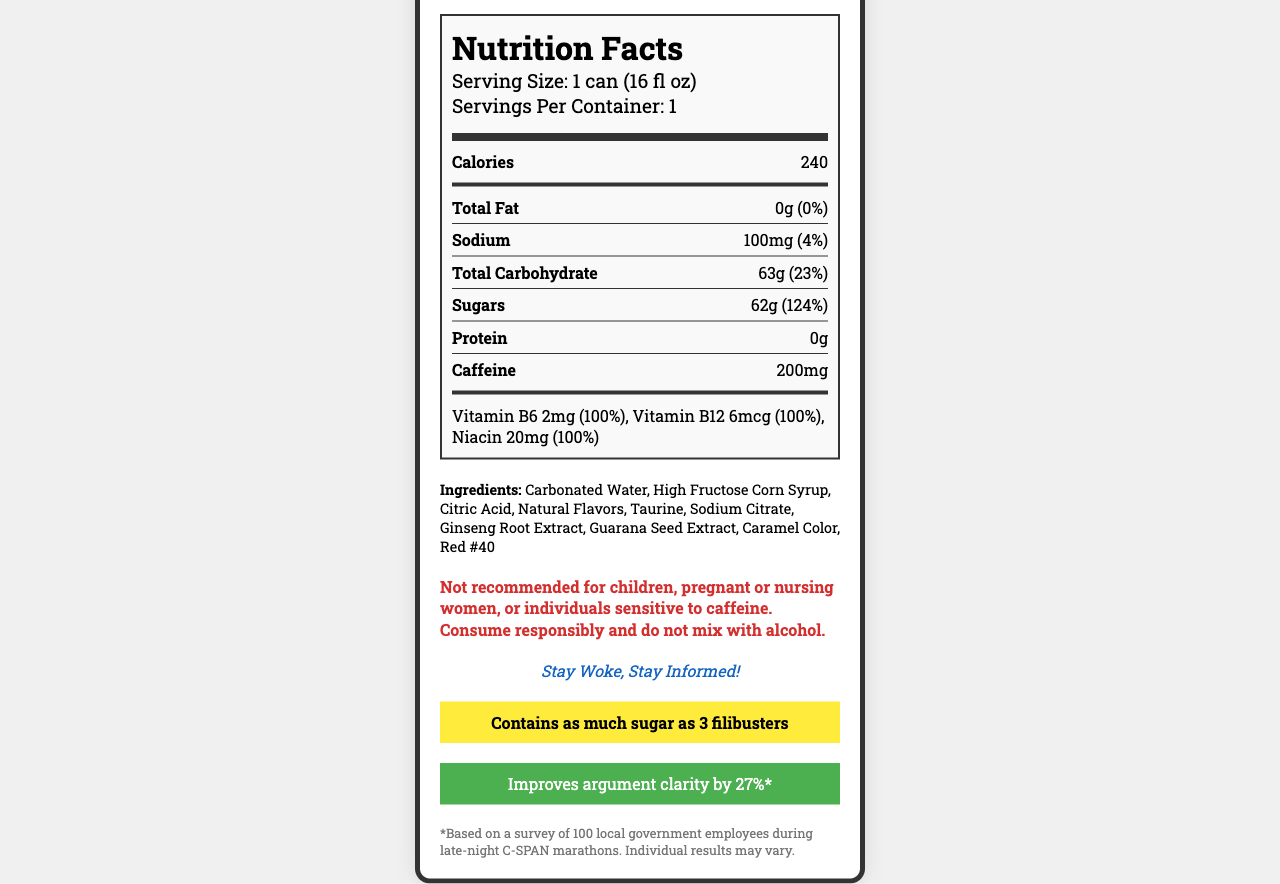what is the product name? The product name is prominently displayed at the top of the document.
Answer: PolitiBoost Energy how many servings are in one container? The document states there is one serving per container.
Answer: 1 what is the serving size? The serving size is listed right below the product name and servings per container information.
Answer: 1 can (16 fl oz) how many calories are in one serving? The number of calories per serving is listed at the beginning of the Nutrition Facts section.
Answer: 240 how much caffeine does this product contain? The amount of caffeine is listed towards the bottom of the nutrient rows.
Answer: 200mg what is the daily value percentage of sugars? The daily value percentage for sugars is provided right next to its amount.
Answer: 124% which vitamin is not present in the list? A. Vitamin C B. Vitamin B12 C. Vitamin B6 D. Niacin The document lists Vitamin B6, Vitamin B12, and Niacin. Vitamin C is not listed.
Answer: A what is the amount of sodium in one serving? The sodium content is listed under the nutrient rows.
Answer: 100mg which ingredient is listed first? A. Citric Acid B. Carbonated Water C. Caffeine D. Taurine The first ingredient listed is Carbonated Water.
Answer: B does this product contain any allergens? The document states that it is manufactured in a facility that processes soy and milk products.
Answer: Yes is this product recommended for children? There is a warning explicitly stating it is not recommended for children.
Answer: No summarize the main idea of the document. The document provides comprehensive information about the energy drink including nutrition content, ingredients, warnings, and promotional claims to give consumers a clear understanding of the product.
Answer: The document details the nutrition facts, ingredients, and some promotional claims of PolitiBoost Energy, an energy drink intended to enhance performance during political debates. what is the slogan of PolitiBoost Energy? The slogan is listed under the warnings section in italics.
Answer: Stay Woke, Stay Informed! how many grams of total fat are in one serving? The total fat in one serving is listed as 0g.
Answer: 0g what color is used emphasize the 'political fact'? The 'political fact' section background color is yellow, making it stand out.
Answer: Yellow what kind of study supports the debate clarity claim? The claim is supported by a survey mentioned in the disclaimer at the bottom of the document.
Answer: A survey of 100 local government employees during late-night C-SPAN marathons. what is the precise amount of Vitamin B12 in the drink? The exact amount of Vitamin B12 present is listed in the vitamins and minerals section.
Answer: 6mcg what is the warning associated with consumption of this energy drink? The warning section gives explicit precautions regarding consumption of the drink.
Answer: Not recommended for children, pregnant or nursing women, or individuals sensitive to caffeine. Consume responsibly and do not mix with alcohol. how many filibusters worth of sugar does the drink contain? The political fact states that the drink contains as much sugar as 3 filibusters.
Answer: 3 when was PolitiBoost Energy first introduced to the market? The document does not provide any information regarding the introduction date of PolitiBoost Energy.
Answer: Cannot be determined 